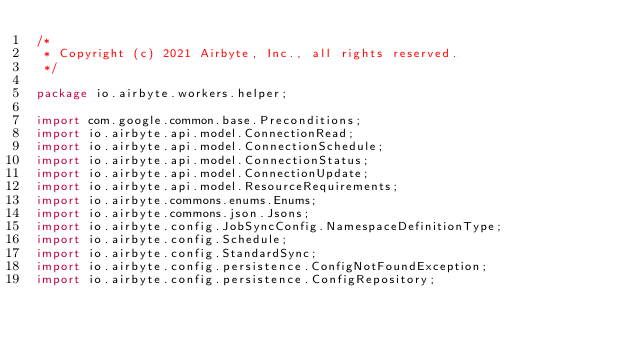<code> <loc_0><loc_0><loc_500><loc_500><_Java_>/*
 * Copyright (c) 2021 Airbyte, Inc., all rights reserved.
 */

package io.airbyte.workers.helper;

import com.google.common.base.Preconditions;
import io.airbyte.api.model.ConnectionRead;
import io.airbyte.api.model.ConnectionSchedule;
import io.airbyte.api.model.ConnectionStatus;
import io.airbyte.api.model.ConnectionUpdate;
import io.airbyte.api.model.ResourceRequirements;
import io.airbyte.commons.enums.Enums;
import io.airbyte.commons.json.Jsons;
import io.airbyte.config.JobSyncConfig.NamespaceDefinitionType;
import io.airbyte.config.Schedule;
import io.airbyte.config.StandardSync;
import io.airbyte.config.persistence.ConfigNotFoundException;
import io.airbyte.config.persistence.ConfigRepository;</code> 